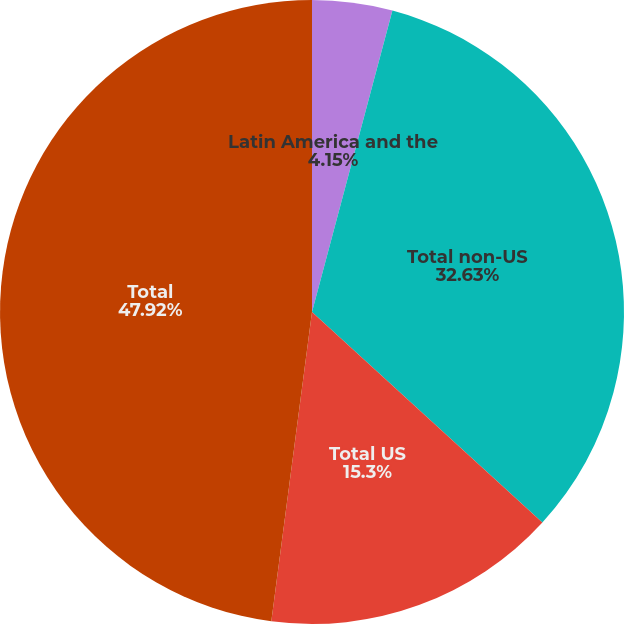Convert chart to OTSL. <chart><loc_0><loc_0><loc_500><loc_500><pie_chart><fcel>Latin America and the<fcel>Total non-US<fcel>Total US<fcel>Total<nl><fcel>4.15%<fcel>32.63%<fcel>15.3%<fcel>47.92%<nl></chart> 